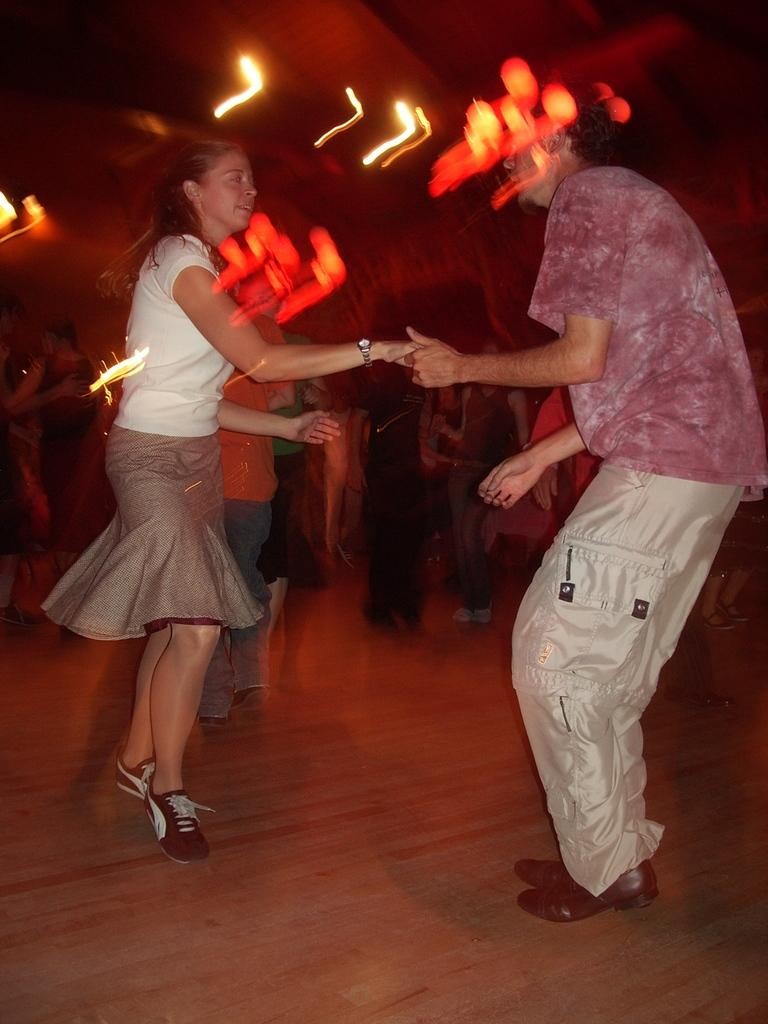What are the people in the image doing? The people in the image are dancing. Where are the people dancing? The people are dancing on the floor. What can be seen in the image besides the people dancing? There are lights visible in the image. Can you describe the background of the image? The background of the image is blurred. What type of bloodstain can be seen on the farmer's crook in the image? There is no farmer, crook, or bloodstain present in the image. The image features people dancing with lights and a blurred background. 